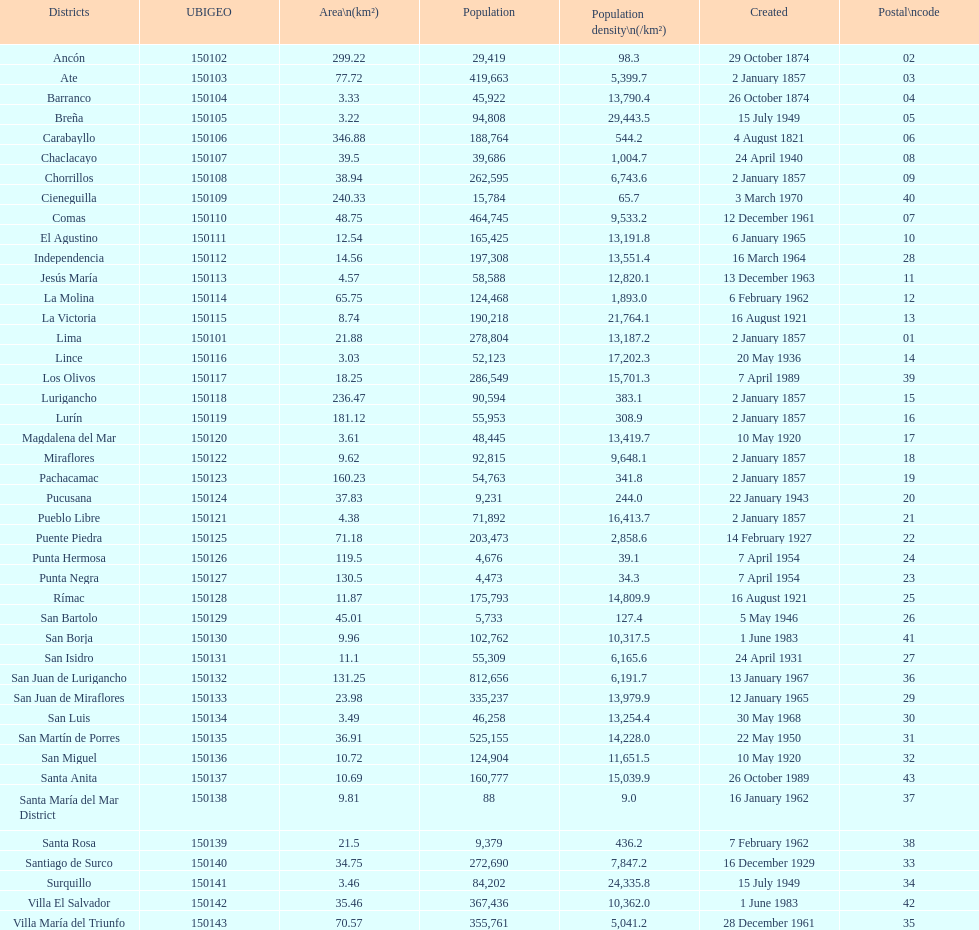What is the total number of districts created in the 1900's? 32. 